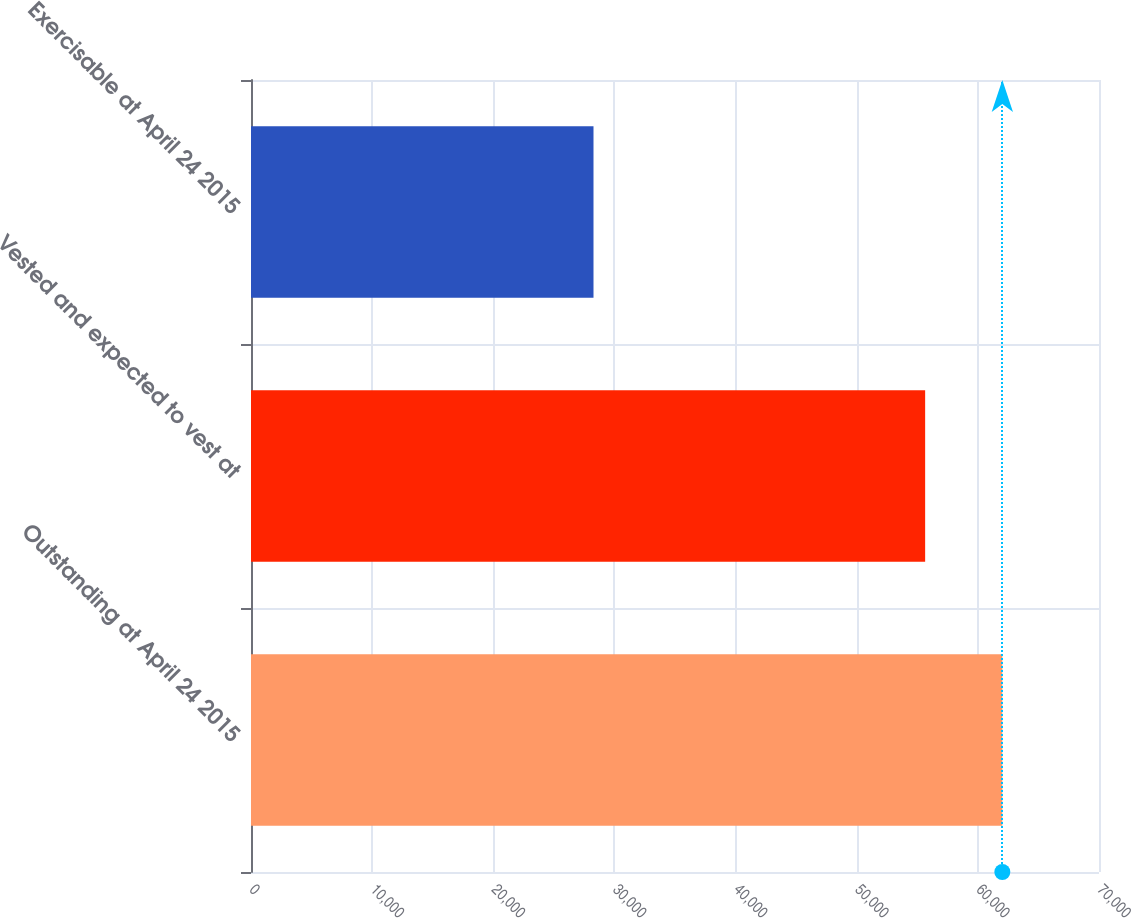Convert chart to OTSL. <chart><loc_0><loc_0><loc_500><loc_500><bar_chart><fcel>Outstanding at April 24 2015<fcel>Vested and expected to vest at<fcel>Exercisable at April 24 2015<nl><fcel>62021<fcel>55649<fcel>28272<nl></chart> 